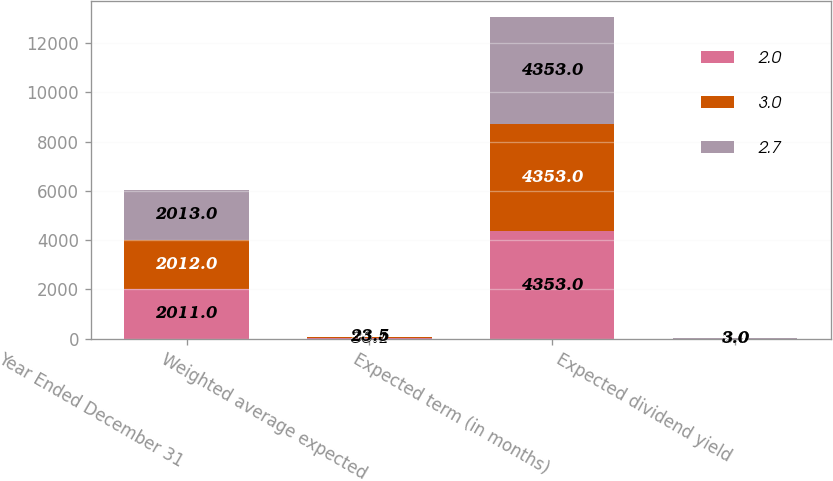<chart> <loc_0><loc_0><loc_500><loc_500><stacked_bar_chart><ecel><fcel>Year Ended December 31<fcel>Weighted average expected<fcel>Expected term (in months)<fcel>Expected dividend yield<nl><fcel>2<fcel>2011<fcel>30.1<fcel>4353<fcel>2<nl><fcel>3<fcel>2012<fcel>30.7<fcel>4353<fcel>2.7<nl><fcel>2.7<fcel>2013<fcel>23.5<fcel>4353<fcel>3<nl></chart> 